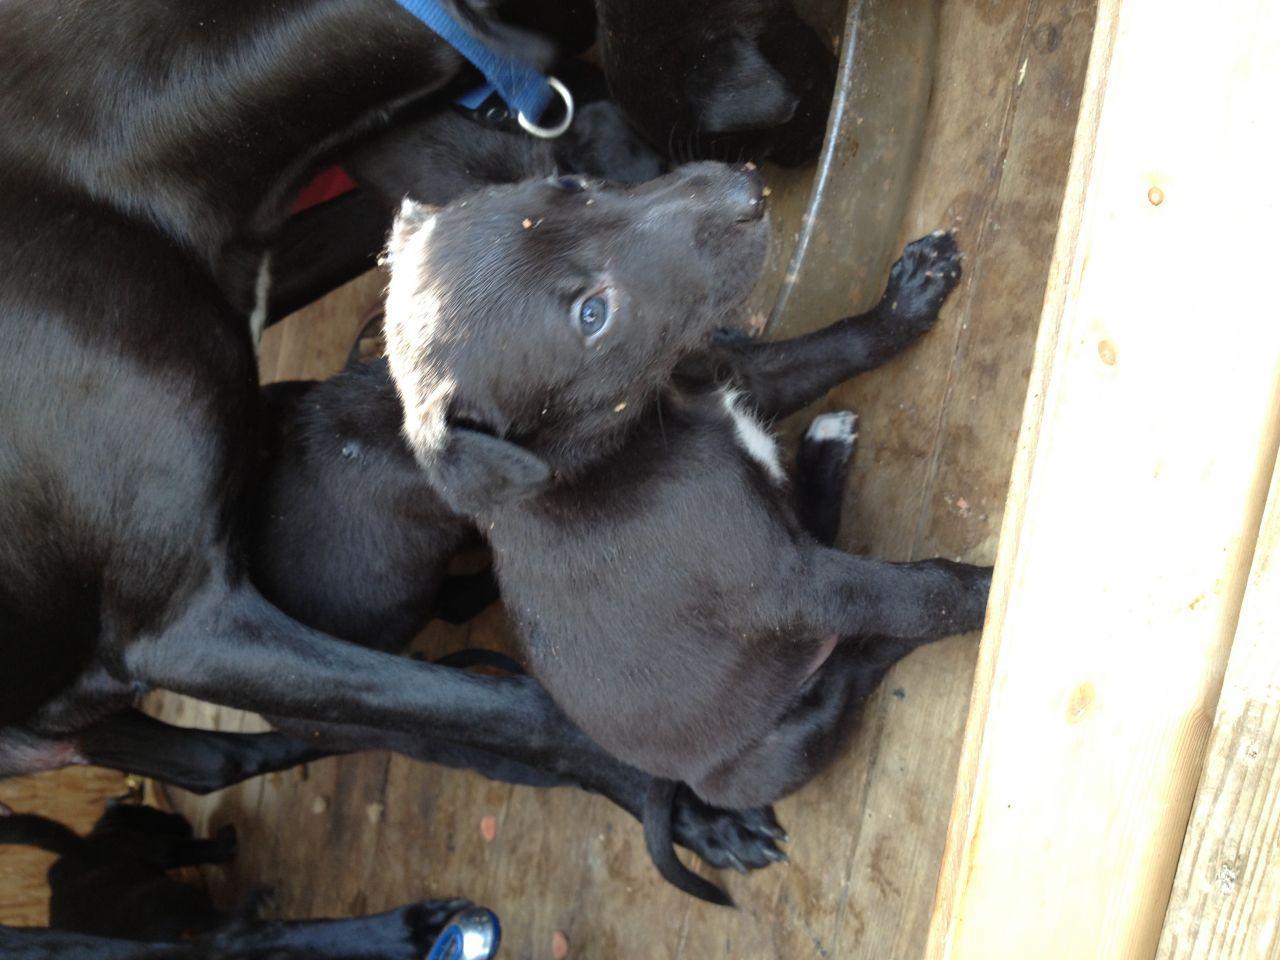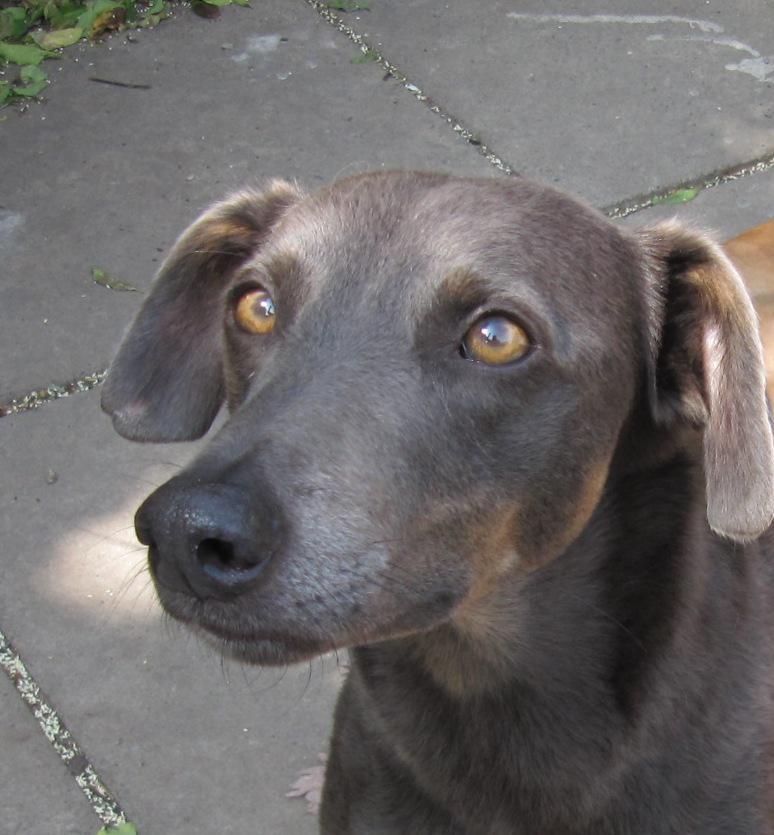The first image is the image on the left, the second image is the image on the right. For the images displayed, is the sentence "There is at least 1 young puppy with it's ears pulled back." factually correct? Answer yes or no. No. 